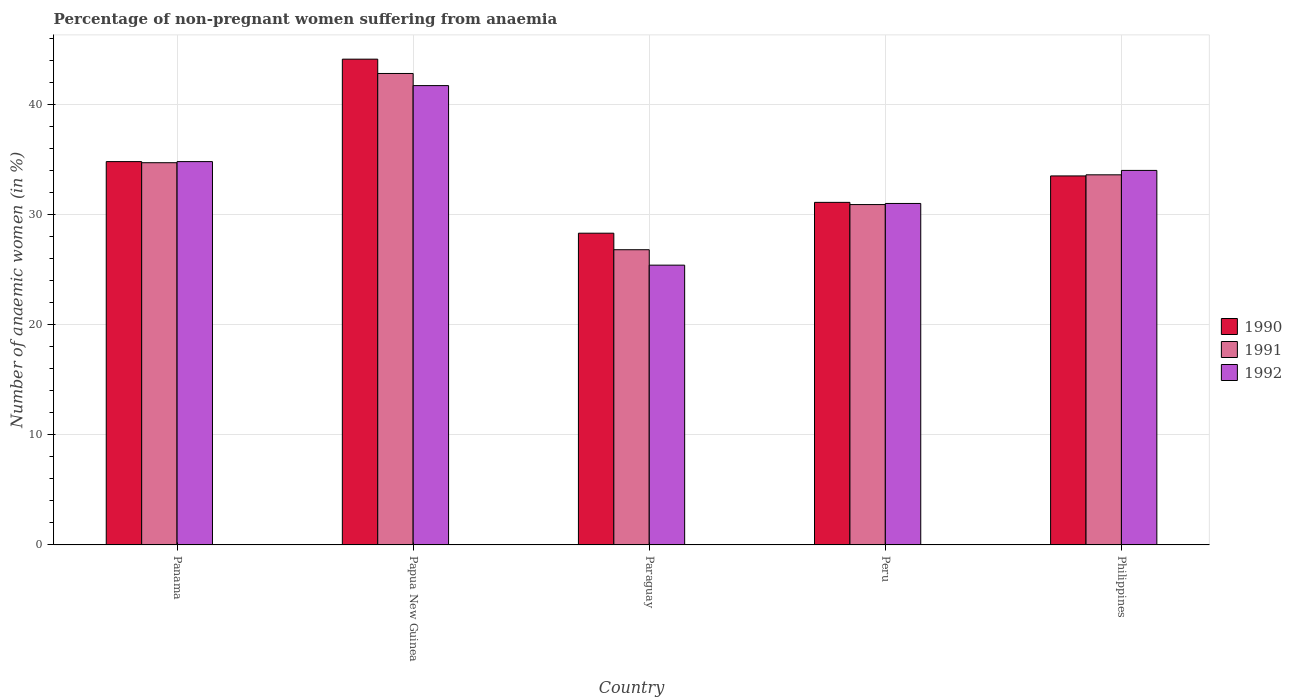How many bars are there on the 5th tick from the left?
Keep it short and to the point. 3. What is the label of the 1st group of bars from the left?
Offer a very short reply. Panama. What is the percentage of non-pregnant women suffering from anaemia in 1991 in Papua New Guinea?
Keep it short and to the point. 42.8. Across all countries, what is the maximum percentage of non-pregnant women suffering from anaemia in 1990?
Provide a succinct answer. 44.1. Across all countries, what is the minimum percentage of non-pregnant women suffering from anaemia in 1991?
Ensure brevity in your answer.  26.8. In which country was the percentage of non-pregnant women suffering from anaemia in 1991 maximum?
Keep it short and to the point. Papua New Guinea. In which country was the percentage of non-pregnant women suffering from anaemia in 1992 minimum?
Ensure brevity in your answer.  Paraguay. What is the total percentage of non-pregnant women suffering from anaemia in 1991 in the graph?
Keep it short and to the point. 168.8. What is the difference between the percentage of non-pregnant women suffering from anaemia in 1991 in Panama and that in Papua New Guinea?
Keep it short and to the point. -8.1. What is the difference between the percentage of non-pregnant women suffering from anaemia in 1990 in Papua New Guinea and the percentage of non-pregnant women suffering from anaemia in 1991 in Peru?
Keep it short and to the point. 13.2. What is the average percentage of non-pregnant women suffering from anaemia in 1990 per country?
Give a very brief answer. 34.36. What is the difference between the percentage of non-pregnant women suffering from anaemia of/in 1990 and percentage of non-pregnant women suffering from anaemia of/in 1992 in Papua New Guinea?
Your answer should be very brief. 2.4. In how many countries, is the percentage of non-pregnant women suffering from anaemia in 1990 greater than 38 %?
Ensure brevity in your answer.  1. What is the ratio of the percentage of non-pregnant women suffering from anaemia in 1992 in Paraguay to that in Philippines?
Provide a succinct answer. 0.75. Is the percentage of non-pregnant women suffering from anaemia in 1992 in Paraguay less than that in Philippines?
Your answer should be compact. Yes. What is the difference between the highest and the second highest percentage of non-pregnant women suffering from anaemia in 1991?
Your response must be concise. -9.2. What is the difference between the highest and the lowest percentage of non-pregnant women suffering from anaemia in 1991?
Keep it short and to the point. 16. In how many countries, is the percentage of non-pregnant women suffering from anaemia in 1992 greater than the average percentage of non-pregnant women suffering from anaemia in 1992 taken over all countries?
Ensure brevity in your answer.  3. Is the sum of the percentage of non-pregnant women suffering from anaemia in 1990 in Papua New Guinea and Paraguay greater than the maximum percentage of non-pregnant women suffering from anaemia in 1991 across all countries?
Your answer should be compact. Yes. What does the 1st bar from the right in Paraguay represents?
Your answer should be compact. 1992. How many countries are there in the graph?
Offer a terse response. 5. What is the difference between two consecutive major ticks on the Y-axis?
Make the answer very short. 10. Does the graph contain any zero values?
Give a very brief answer. No. Where does the legend appear in the graph?
Your answer should be very brief. Center right. How many legend labels are there?
Your response must be concise. 3. How are the legend labels stacked?
Your answer should be compact. Vertical. What is the title of the graph?
Your answer should be compact. Percentage of non-pregnant women suffering from anaemia. Does "2012" appear as one of the legend labels in the graph?
Give a very brief answer. No. What is the label or title of the X-axis?
Keep it short and to the point. Country. What is the label or title of the Y-axis?
Keep it short and to the point. Number of anaemic women (in %). What is the Number of anaemic women (in %) in 1990 in Panama?
Offer a very short reply. 34.8. What is the Number of anaemic women (in %) of 1991 in Panama?
Ensure brevity in your answer.  34.7. What is the Number of anaemic women (in %) in 1992 in Panama?
Your answer should be very brief. 34.8. What is the Number of anaemic women (in %) in 1990 in Papua New Guinea?
Provide a succinct answer. 44.1. What is the Number of anaemic women (in %) of 1991 in Papua New Guinea?
Make the answer very short. 42.8. What is the Number of anaemic women (in %) in 1992 in Papua New Guinea?
Keep it short and to the point. 41.7. What is the Number of anaemic women (in %) of 1990 in Paraguay?
Your response must be concise. 28.3. What is the Number of anaemic women (in %) of 1991 in Paraguay?
Provide a short and direct response. 26.8. What is the Number of anaemic women (in %) in 1992 in Paraguay?
Keep it short and to the point. 25.4. What is the Number of anaemic women (in %) of 1990 in Peru?
Make the answer very short. 31.1. What is the Number of anaemic women (in %) of 1991 in Peru?
Make the answer very short. 30.9. What is the Number of anaemic women (in %) in 1992 in Peru?
Ensure brevity in your answer.  31. What is the Number of anaemic women (in %) of 1990 in Philippines?
Provide a succinct answer. 33.5. What is the Number of anaemic women (in %) of 1991 in Philippines?
Your answer should be very brief. 33.6. What is the Number of anaemic women (in %) of 1992 in Philippines?
Offer a terse response. 34. Across all countries, what is the maximum Number of anaemic women (in %) of 1990?
Offer a terse response. 44.1. Across all countries, what is the maximum Number of anaemic women (in %) in 1991?
Offer a very short reply. 42.8. Across all countries, what is the maximum Number of anaemic women (in %) in 1992?
Provide a succinct answer. 41.7. Across all countries, what is the minimum Number of anaemic women (in %) in 1990?
Give a very brief answer. 28.3. Across all countries, what is the minimum Number of anaemic women (in %) of 1991?
Give a very brief answer. 26.8. Across all countries, what is the minimum Number of anaemic women (in %) in 1992?
Provide a succinct answer. 25.4. What is the total Number of anaemic women (in %) in 1990 in the graph?
Give a very brief answer. 171.8. What is the total Number of anaemic women (in %) in 1991 in the graph?
Ensure brevity in your answer.  168.8. What is the total Number of anaemic women (in %) in 1992 in the graph?
Your response must be concise. 166.9. What is the difference between the Number of anaemic women (in %) in 1991 in Panama and that in Paraguay?
Provide a succinct answer. 7.9. What is the difference between the Number of anaemic women (in %) in 1992 in Panama and that in Paraguay?
Offer a terse response. 9.4. What is the difference between the Number of anaemic women (in %) of 1990 in Papua New Guinea and that in Paraguay?
Offer a very short reply. 15.8. What is the difference between the Number of anaemic women (in %) in 1992 in Papua New Guinea and that in Paraguay?
Make the answer very short. 16.3. What is the difference between the Number of anaemic women (in %) of 1990 in Papua New Guinea and that in Peru?
Make the answer very short. 13. What is the difference between the Number of anaemic women (in %) in 1991 in Papua New Guinea and that in Peru?
Your answer should be compact. 11.9. What is the difference between the Number of anaemic women (in %) in 1992 in Papua New Guinea and that in Peru?
Ensure brevity in your answer.  10.7. What is the difference between the Number of anaemic women (in %) of 1991 in Papua New Guinea and that in Philippines?
Make the answer very short. 9.2. What is the difference between the Number of anaemic women (in %) in 1992 in Papua New Guinea and that in Philippines?
Keep it short and to the point. 7.7. What is the difference between the Number of anaemic women (in %) in 1990 in Paraguay and that in Peru?
Offer a very short reply. -2.8. What is the difference between the Number of anaemic women (in %) of 1991 in Paraguay and that in Peru?
Give a very brief answer. -4.1. What is the difference between the Number of anaemic women (in %) in 1990 in Paraguay and that in Philippines?
Your answer should be very brief. -5.2. What is the difference between the Number of anaemic women (in %) in 1990 in Peru and that in Philippines?
Your answer should be very brief. -2.4. What is the difference between the Number of anaemic women (in %) in 1991 in Peru and that in Philippines?
Your response must be concise. -2.7. What is the difference between the Number of anaemic women (in %) of 1990 in Panama and the Number of anaemic women (in %) of 1991 in Papua New Guinea?
Your response must be concise. -8. What is the difference between the Number of anaemic women (in %) of 1990 in Panama and the Number of anaemic women (in %) of 1991 in Paraguay?
Provide a succinct answer. 8. What is the difference between the Number of anaemic women (in %) of 1990 in Panama and the Number of anaemic women (in %) of 1992 in Paraguay?
Provide a succinct answer. 9.4. What is the difference between the Number of anaemic women (in %) of 1991 in Panama and the Number of anaemic women (in %) of 1992 in Peru?
Offer a terse response. 3.7. What is the difference between the Number of anaemic women (in %) in 1990 in Panama and the Number of anaemic women (in %) in 1992 in Philippines?
Make the answer very short. 0.8. What is the difference between the Number of anaemic women (in %) in 1991 in Panama and the Number of anaemic women (in %) in 1992 in Philippines?
Provide a succinct answer. 0.7. What is the difference between the Number of anaemic women (in %) of 1990 in Papua New Guinea and the Number of anaemic women (in %) of 1991 in Paraguay?
Provide a succinct answer. 17.3. What is the difference between the Number of anaemic women (in %) in 1990 in Papua New Guinea and the Number of anaemic women (in %) in 1992 in Paraguay?
Your response must be concise. 18.7. What is the difference between the Number of anaemic women (in %) in 1991 in Papua New Guinea and the Number of anaemic women (in %) in 1992 in Paraguay?
Provide a short and direct response. 17.4. What is the difference between the Number of anaemic women (in %) of 1990 in Papua New Guinea and the Number of anaemic women (in %) of 1991 in Peru?
Offer a very short reply. 13.2. What is the difference between the Number of anaemic women (in %) of 1990 in Papua New Guinea and the Number of anaemic women (in %) of 1991 in Philippines?
Your answer should be very brief. 10.5. What is the difference between the Number of anaemic women (in %) of 1990 in Paraguay and the Number of anaemic women (in %) of 1991 in Peru?
Provide a succinct answer. -2.6. What is the difference between the Number of anaemic women (in %) of 1990 in Paraguay and the Number of anaemic women (in %) of 1991 in Philippines?
Keep it short and to the point. -5.3. What is the difference between the Number of anaemic women (in %) in 1990 in Peru and the Number of anaemic women (in %) in 1992 in Philippines?
Your answer should be very brief. -2.9. What is the difference between the Number of anaemic women (in %) of 1991 in Peru and the Number of anaemic women (in %) of 1992 in Philippines?
Your answer should be compact. -3.1. What is the average Number of anaemic women (in %) in 1990 per country?
Offer a terse response. 34.36. What is the average Number of anaemic women (in %) of 1991 per country?
Provide a succinct answer. 33.76. What is the average Number of anaemic women (in %) of 1992 per country?
Your answer should be compact. 33.38. What is the difference between the Number of anaemic women (in %) of 1990 and Number of anaemic women (in %) of 1992 in Panama?
Make the answer very short. 0. What is the difference between the Number of anaemic women (in %) of 1991 and Number of anaemic women (in %) of 1992 in Panama?
Your response must be concise. -0.1. What is the difference between the Number of anaemic women (in %) in 1990 and Number of anaemic women (in %) in 1991 in Papua New Guinea?
Make the answer very short. 1.3. What is the difference between the Number of anaemic women (in %) in 1990 and Number of anaemic women (in %) in 1992 in Papua New Guinea?
Your response must be concise. 2.4. What is the difference between the Number of anaemic women (in %) of 1991 and Number of anaemic women (in %) of 1992 in Papua New Guinea?
Provide a succinct answer. 1.1. What is the difference between the Number of anaemic women (in %) of 1990 and Number of anaemic women (in %) of 1991 in Paraguay?
Make the answer very short. 1.5. What is the difference between the Number of anaemic women (in %) of 1991 and Number of anaemic women (in %) of 1992 in Paraguay?
Provide a short and direct response. 1.4. What is the difference between the Number of anaemic women (in %) in 1990 and Number of anaemic women (in %) in 1991 in Peru?
Provide a short and direct response. 0.2. What is the difference between the Number of anaemic women (in %) in 1991 and Number of anaemic women (in %) in 1992 in Peru?
Ensure brevity in your answer.  -0.1. What is the difference between the Number of anaemic women (in %) of 1991 and Number of anaemic women (in %) of 1992 in Philippines?
Provide a succinct answer. -0.4. What is the ratio of the Number of anaemic women (in %) in 1990 in Panama to that in Papua New Guinea?
Your answer should be compact. 0.79. What is the ratio of the Number of anaemic women (in %) of 1991 in Panama to that in Papua New Guinea?
Provide a succinct answer. 0.81. What is the ratio of the Number of anaemic women (in %) in 1992 in Panama to that in Papua New Guinea?
Your response must be concise. 0.83. What is the ratio of the Number of anaemic women (in %) of 1990 in Panama to that in Paraguay?
Keep it short and to the point. 1.23. What is the ratio of the Number of anaemic women (in %) in 1991 in Panama to that in Paraguay?
Give a very brief answer. 1.29. What is the ratio of the Number of anaemic women (in %) in 1992 in Panama to that in Paraguay?
Give a very brief answer. 1.37. What is the ratio of the Number of anaemic women (in %) of 1990 in Panama to that in Peru?
Offer a terse response. 1.12. What is the ratio of the Number of anaemic women (in %) in 1991 in Panama to that in Peru?
Provide a succinct answer. 1.12. What is the ratio of the Number of anaemic women (in %) in 1992 in Panama to that in Peru?
Make the answer very short. 1.12. What is the ratio of the Number of anaemic women (in %) in 1990 in Panama to that in Philippines?
Your answer should be very brief. 1.04. What is the ratio of the Number of anaemic women (in %) in 1991 in Panama to that in Philippines?
Provide a succinct answer. 1.03. What is the ratio of the Number of anaemic women (in %) in 1992 in Panama to that in Philippines?
Give a very brief answer. 1.02. What is the ratio of the Number of anaemic women (in %) of 1990 in Papua New Guinea to that in Paraguay?
Give a very brief answer. 1.56. What is the ratio of the Number of anaemic women (in %) of 1991 in Papua New Guinea to that in Paraguay?
Ensure brevity in your answer.  1.6. What is the ratio of the Number of anaemic women (in %) in 1992 in Papua New Guinea to that in Paraguay?
Provide a short and direct response. 1.64. What is the ratio of the Number of anaemic women (in %) of 1990 in Papua New Guinea to that in Peru?
Offer a terse response. 1.42. What is the ratio of the Number of anaemic women (in %) in 1991 in Papua New Guinea to that in Peru?
Your answer should be compact. 1.39. What is the ratio of the Number of anaemic women (in %) in 1992 in Papua New Guinea to that in Peru?
Offer a terse response. 1.35. What is the ratio of the Number of anaemic women (in %) in 1990 in Papua New Guinea to that in Philippines?
Provide a succinct answer. 1.32. What is the ratio of the Number of anaemic women (in %) in 1991 in Papua New Guinea to that in Philippines?
Ensure brevity in your answer.  1.27. What is the ratio of the Number of anaemic women (in %) of 1992 in Papua New Guinea to that in Philippines?
Make the answer very short. 1.23. What is the ratio of the Number of anaemic women (in %) of 1990 in Paraguay to that in Peru?
Make the answer very short. 0.91. What is the ratio of the Number of anaemic women (in %) in 1991 in Paraguay to that in Peru?
Your response must be concise. 0.87. What is the ratio of the Number of anaemic women (in %) in 1992 in Paraguay to that in Peru?
Keep it short and to the point. 0.82. What is the ratio of the Number of anaemic women (in %) in 1990 in Paraguay to that in Philippines?
Offer a very short reply. 0.84. What is the ratio of the Number of anaemic women (in %) of 1991 in Paraguay to that in Philippines?
Ensure brevity in your answer.  0.8. What is the ratio of the Number of anaemic women (in %) of 1992 in Paraguay to that in Philippines?
Provide a short and direct response. 0.75. What is the ratio of the Number of anaemic women (in %) in 1990 in Peru to that in Philippines?
Keep it short and to the point. 0.93. What is the ratio of the Number of anaemic women (in %) of 1991 in Peru to that in Philippines?
Keep it short and to the point. 0.92. What is the ratio of the Number of anaemic women (in %) in 1992 in Peru to that in Philippines?
Offer a terse response. 0.91. What is the difference between the highest and the second highest Number of anaemic women (in %) in 1992?
Give a very brief answer. 6.9. What is the difference between the highest and the lowest Number of anaemic women (in %) in 1990?
Keep it short and to the point. 15.8. What is the difference between the highest and the lowest Number of anaemic women (in %) of 1992?
Your response must be concise. 16.3. 